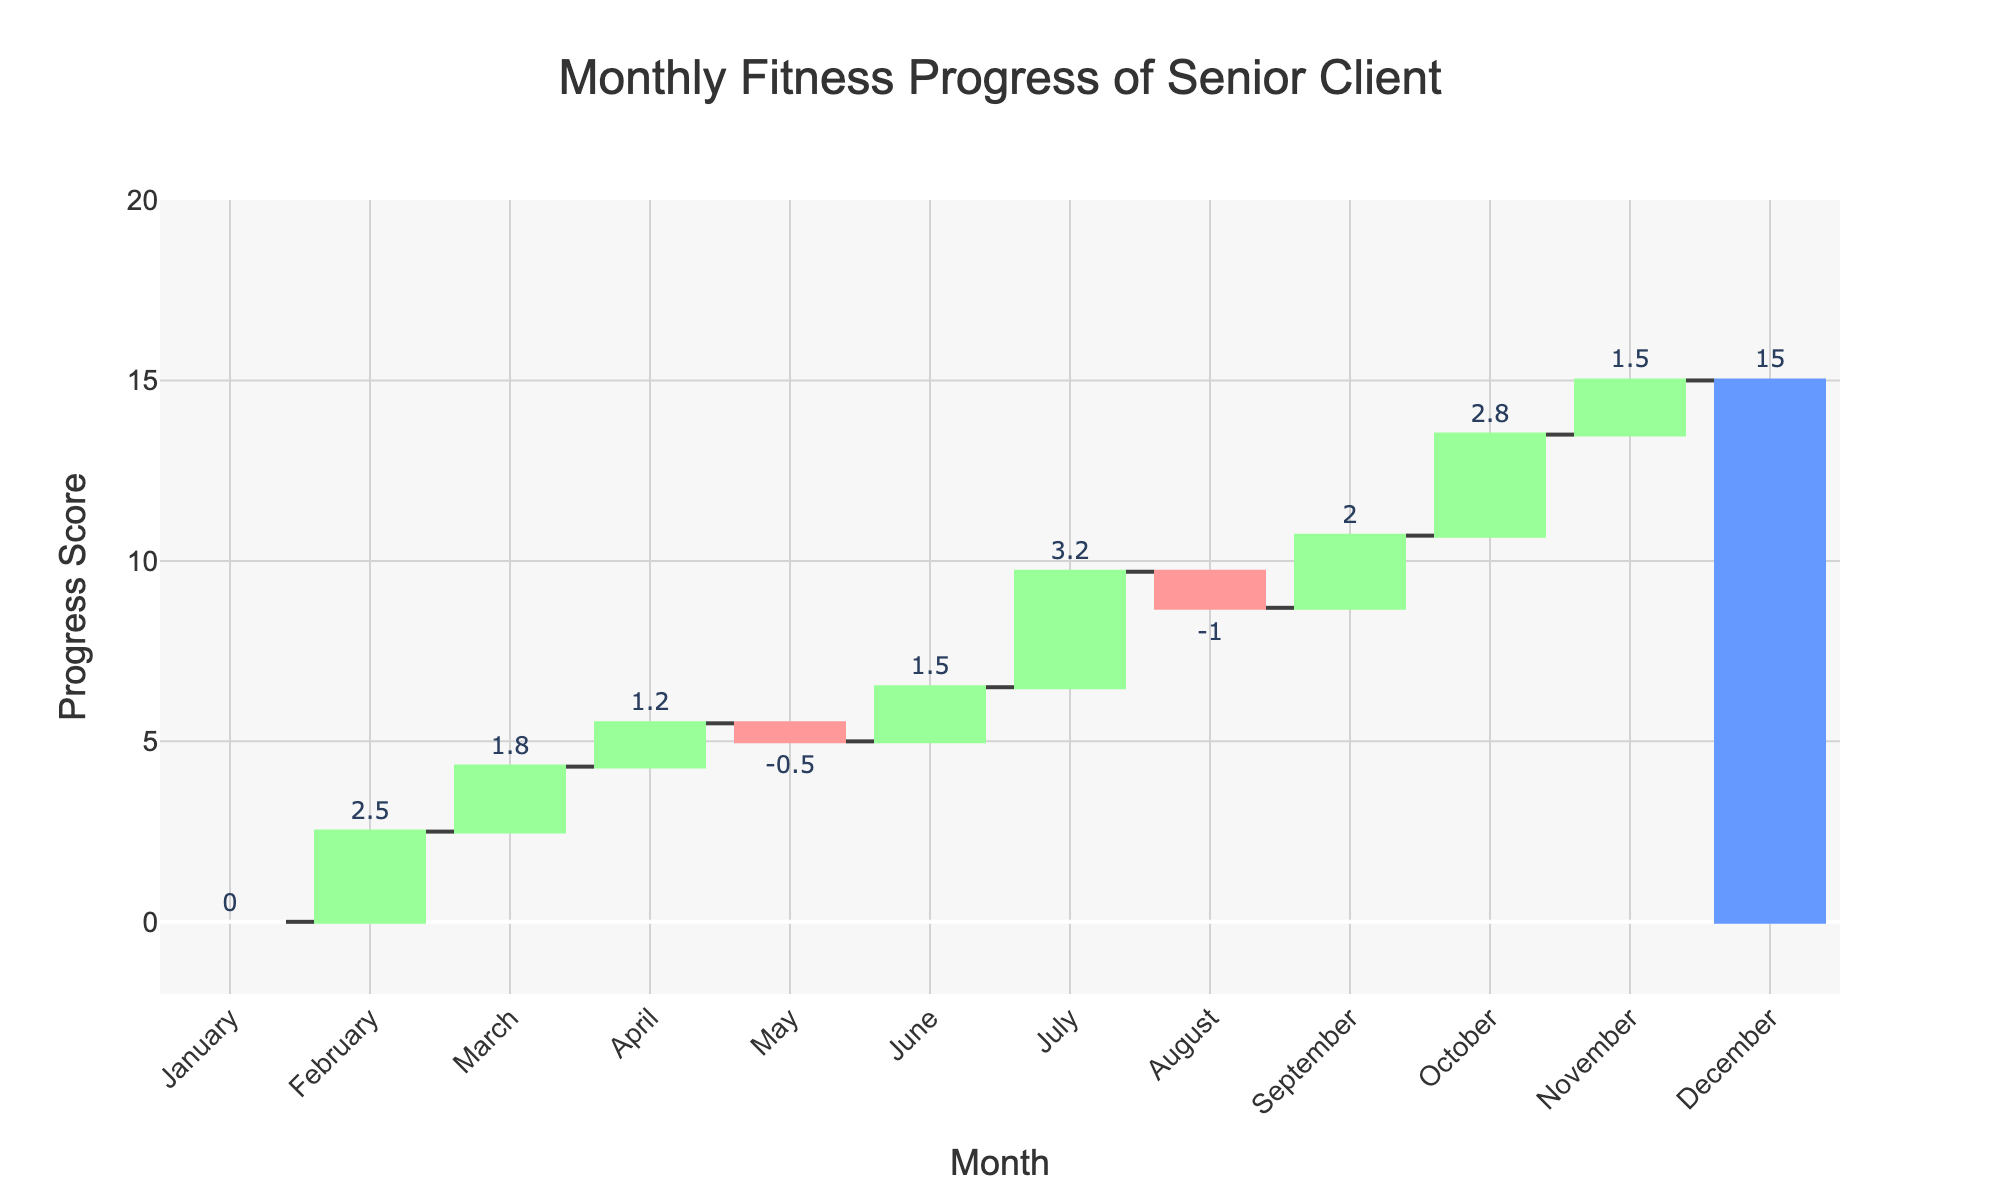What is the title of the figure? The title of the chart is usually prominently displayed at the top of the figure.
Answer: Monthly Fitness Progress of Senior Client How many months show improvement in cardiovascular endurance? To answer this, identify the months labelled with "Cardiovascular Endurance Boost" and count how many there are.
Answer: 2 Which month had a decline in strength? Look for the month that has a negative value marked for "Strength" related categories.
Answer: August What was the initial strength value in January? The initial strength value should be the first data point labeled "Initial Strength" for January.
Answer: 0 What is the total progress score by December? The total progress score can be seen at the end of the series, usually in a distinct color, labeled "Final Progress" for December.
Answer: 15.0 What is the net change in flexibility from May to September? Identify the values for "Flexibility Change" in May and "Flexibility Improvement" in both June and September, then sum these changes: (-0.5) + 1.5 + 2.0 = 3.0.
Answer: 3.0 Which month had the highest individual improvement and in which category? For this, look for the month with the highest positive value. Here, July has a "Cardiovascular Endurance Boost" with a score of 3.2.
Answer: July, Cardiovascular Endurance Boost What is the average monthly strength improvement from February to November? Sum the monthly strength improvements and divide by the number of months: (2.5 + 1.8 + 1.2 - 1.0 + 1.5) / 5. The denominator is 5 months.
Answer: 1.2 By how much did the final progress in December differ from the initial strength in January? Subtract the initial strength in January from the final progress in December: 15.0 - 0 = 15.
Answer: 15 How many months showed a total decline in any fitness category? Count the months with negative values. Here, May and August both have negative values.
Answer: 2 